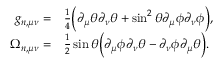Convert formula to latex. <formula><loc_0><loc_0><loc_500><loc_500>\begin{array} { r l } { g _ { n , \mu \nu } = } & { \frac { 1 } { 4 } \left ( \partial _ { \mu } \theta \partial _ { \nu } \theta + \sin ^ { 2 } \theta \partial _ { \mu } \phi \partial _ { \nu } \phi \right ) , } \\ { \Omega _ { n , \mu \nu } = } & { \frac { 1 } { 2 } \sin \theta \left ( \partial _ { \mu } \phi \partial _ { \nu } \theta - \partial _ { \nu } \phi \partial _ { \mu } \theta \right ) . } \end{array}</formula> 